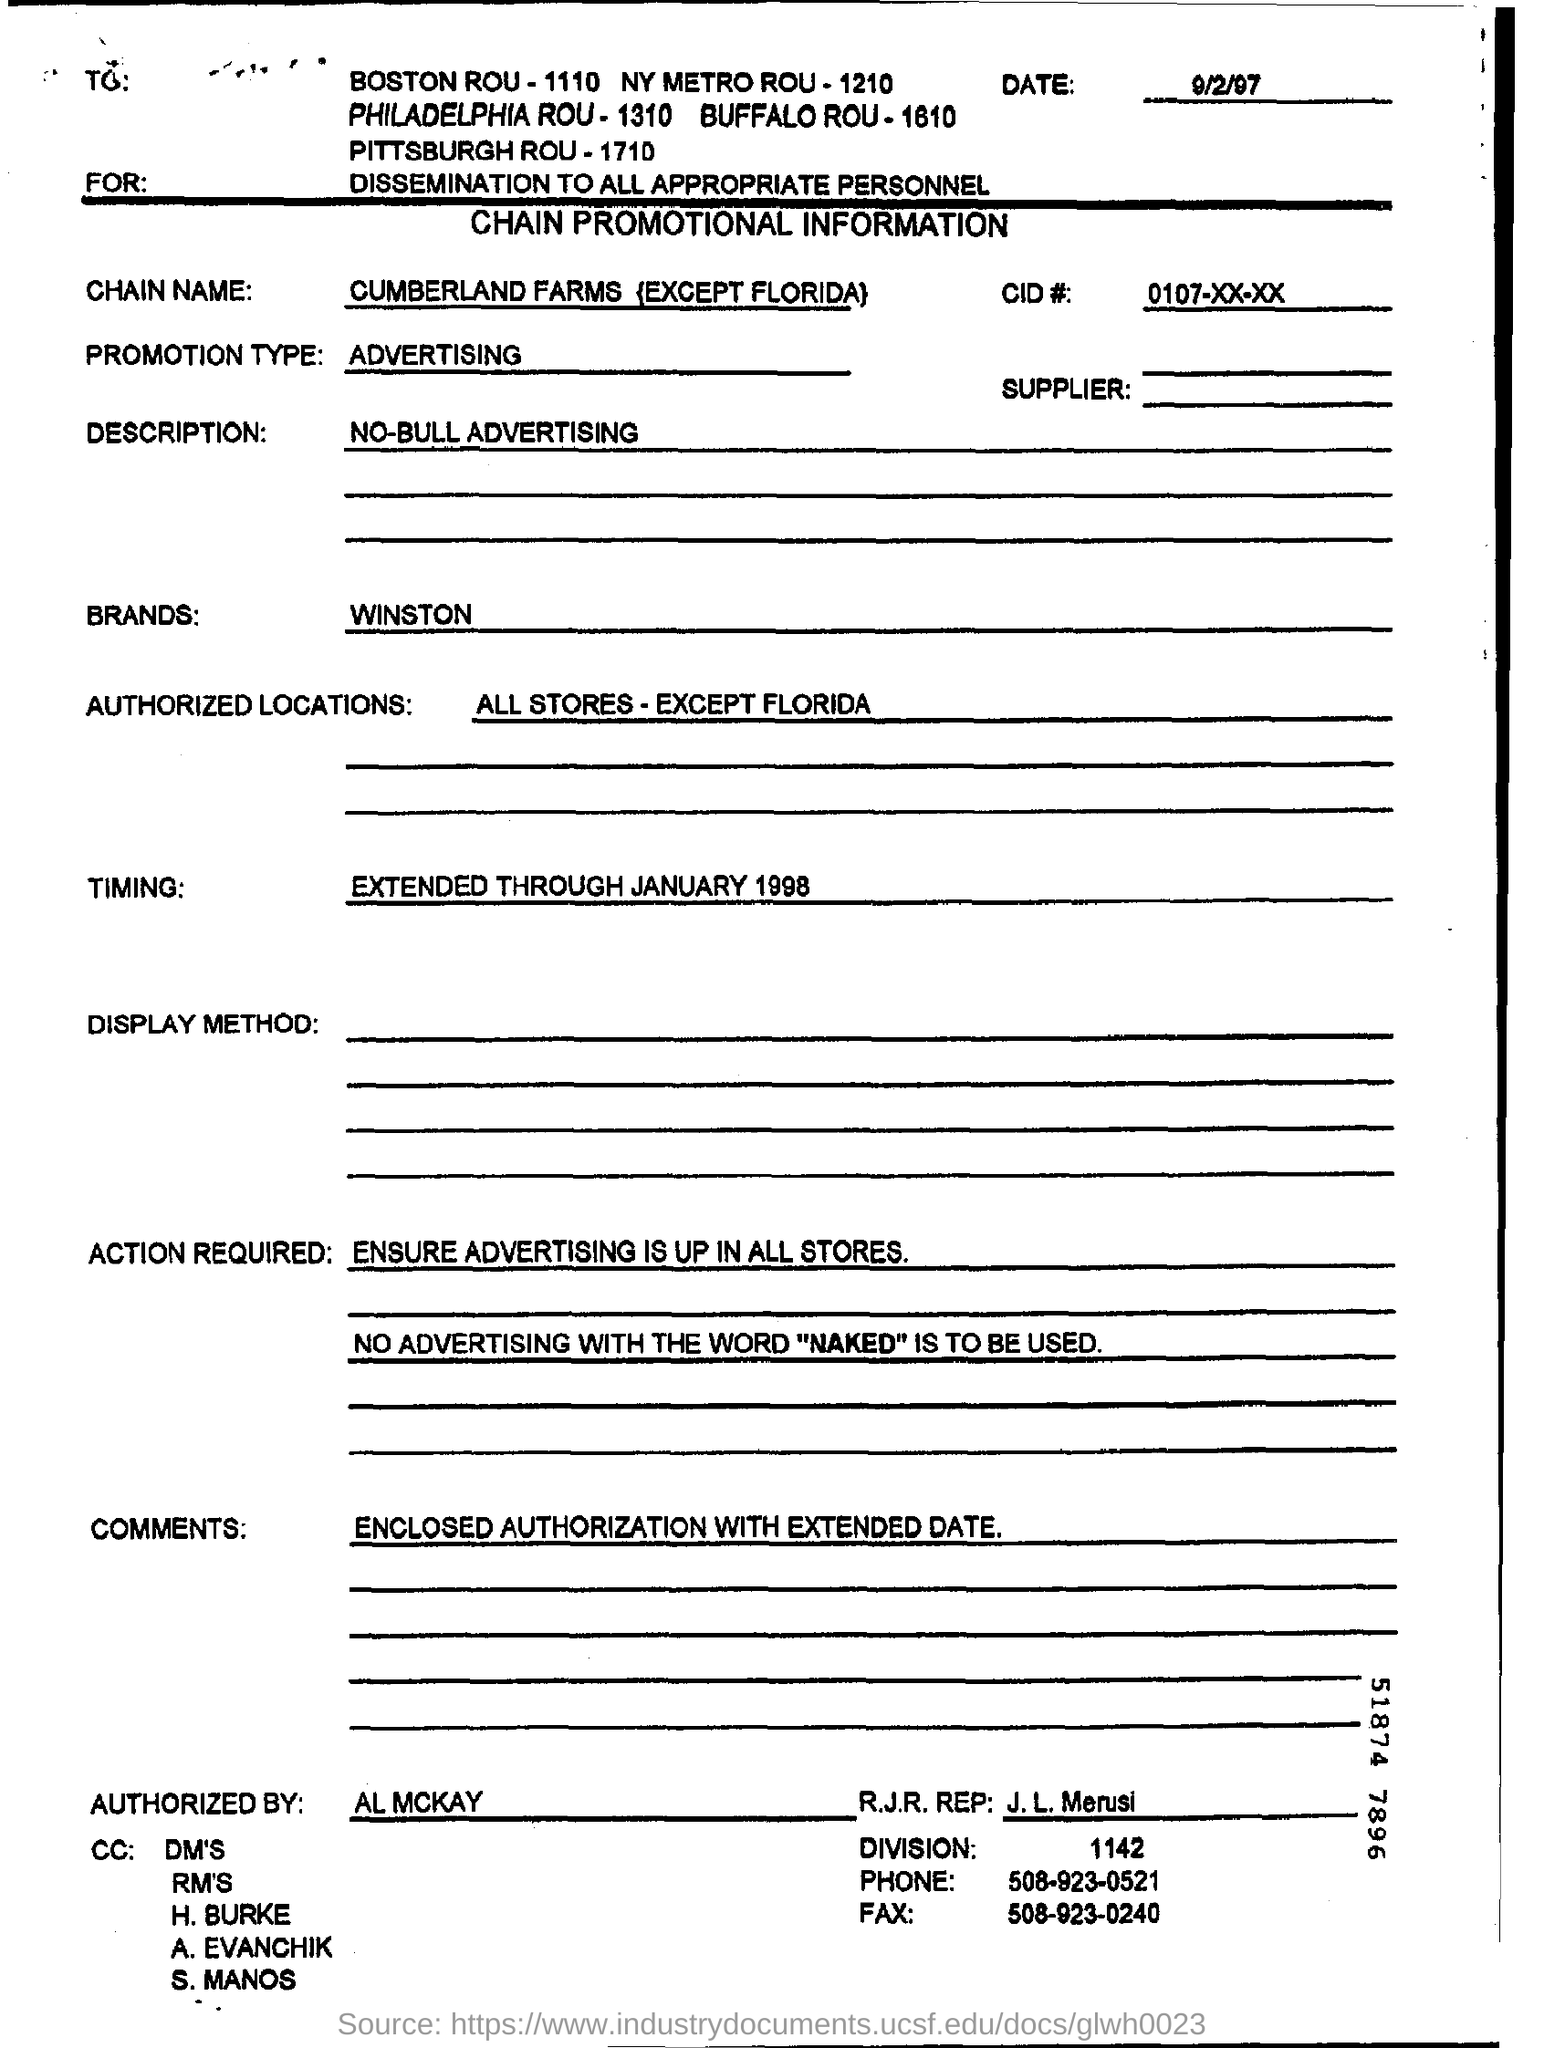What is the CHAIN NAME?
Your response must be concise. CUMBERLAND FARMS{EXCEPT FLORIDA}. What are the authorized  locations?
Keep it short and to the point. ALL STORES-EXCEPT FLORIDA. Who authorized the form?
Offer a very short reply. AL MCKAY. What is R.J.R. REP FAX No?
Your response must be concise. 508-923-0240. 